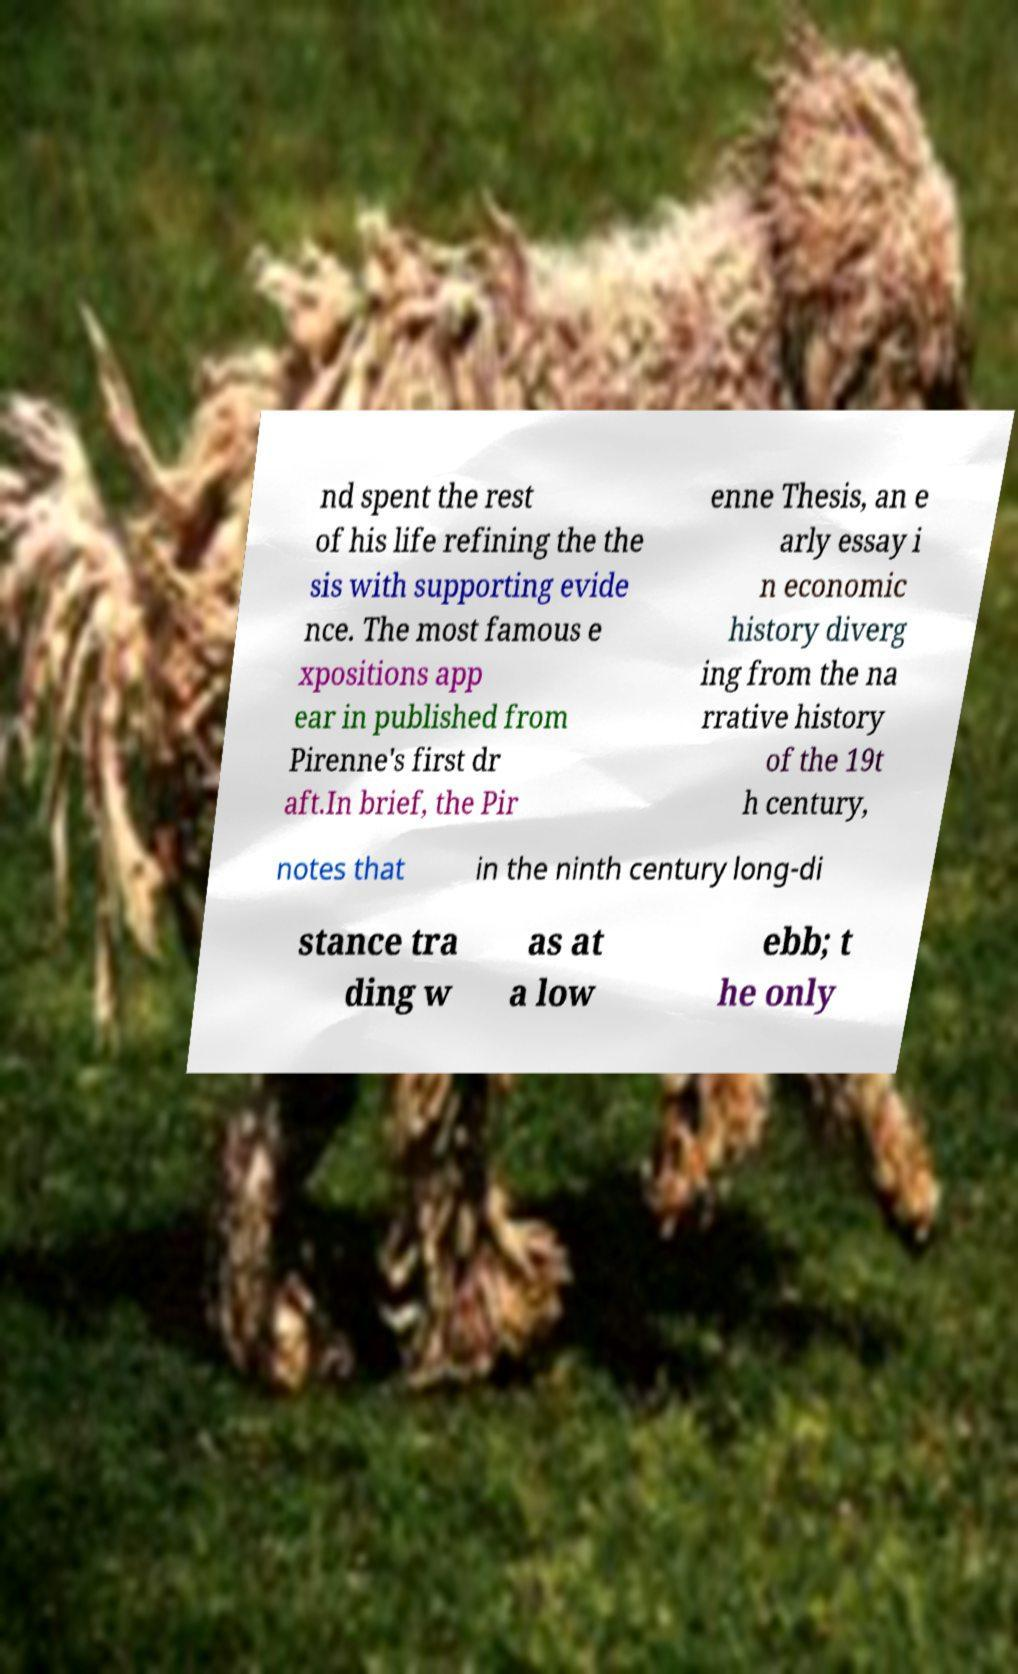Could you extract and type out the text from this image? nd spent the rest of his life refining the the sis with supporting evide nce. The most famous e xpositions app ear in published from Pirenne's first dr aft.In brief, the Pir enne Thesis, an e arly essay i n economic history diverg ing from the na rrative history of the 19t h century, notes that in the ninth century long-di stance tra ding w as at a low ebb; t he only 